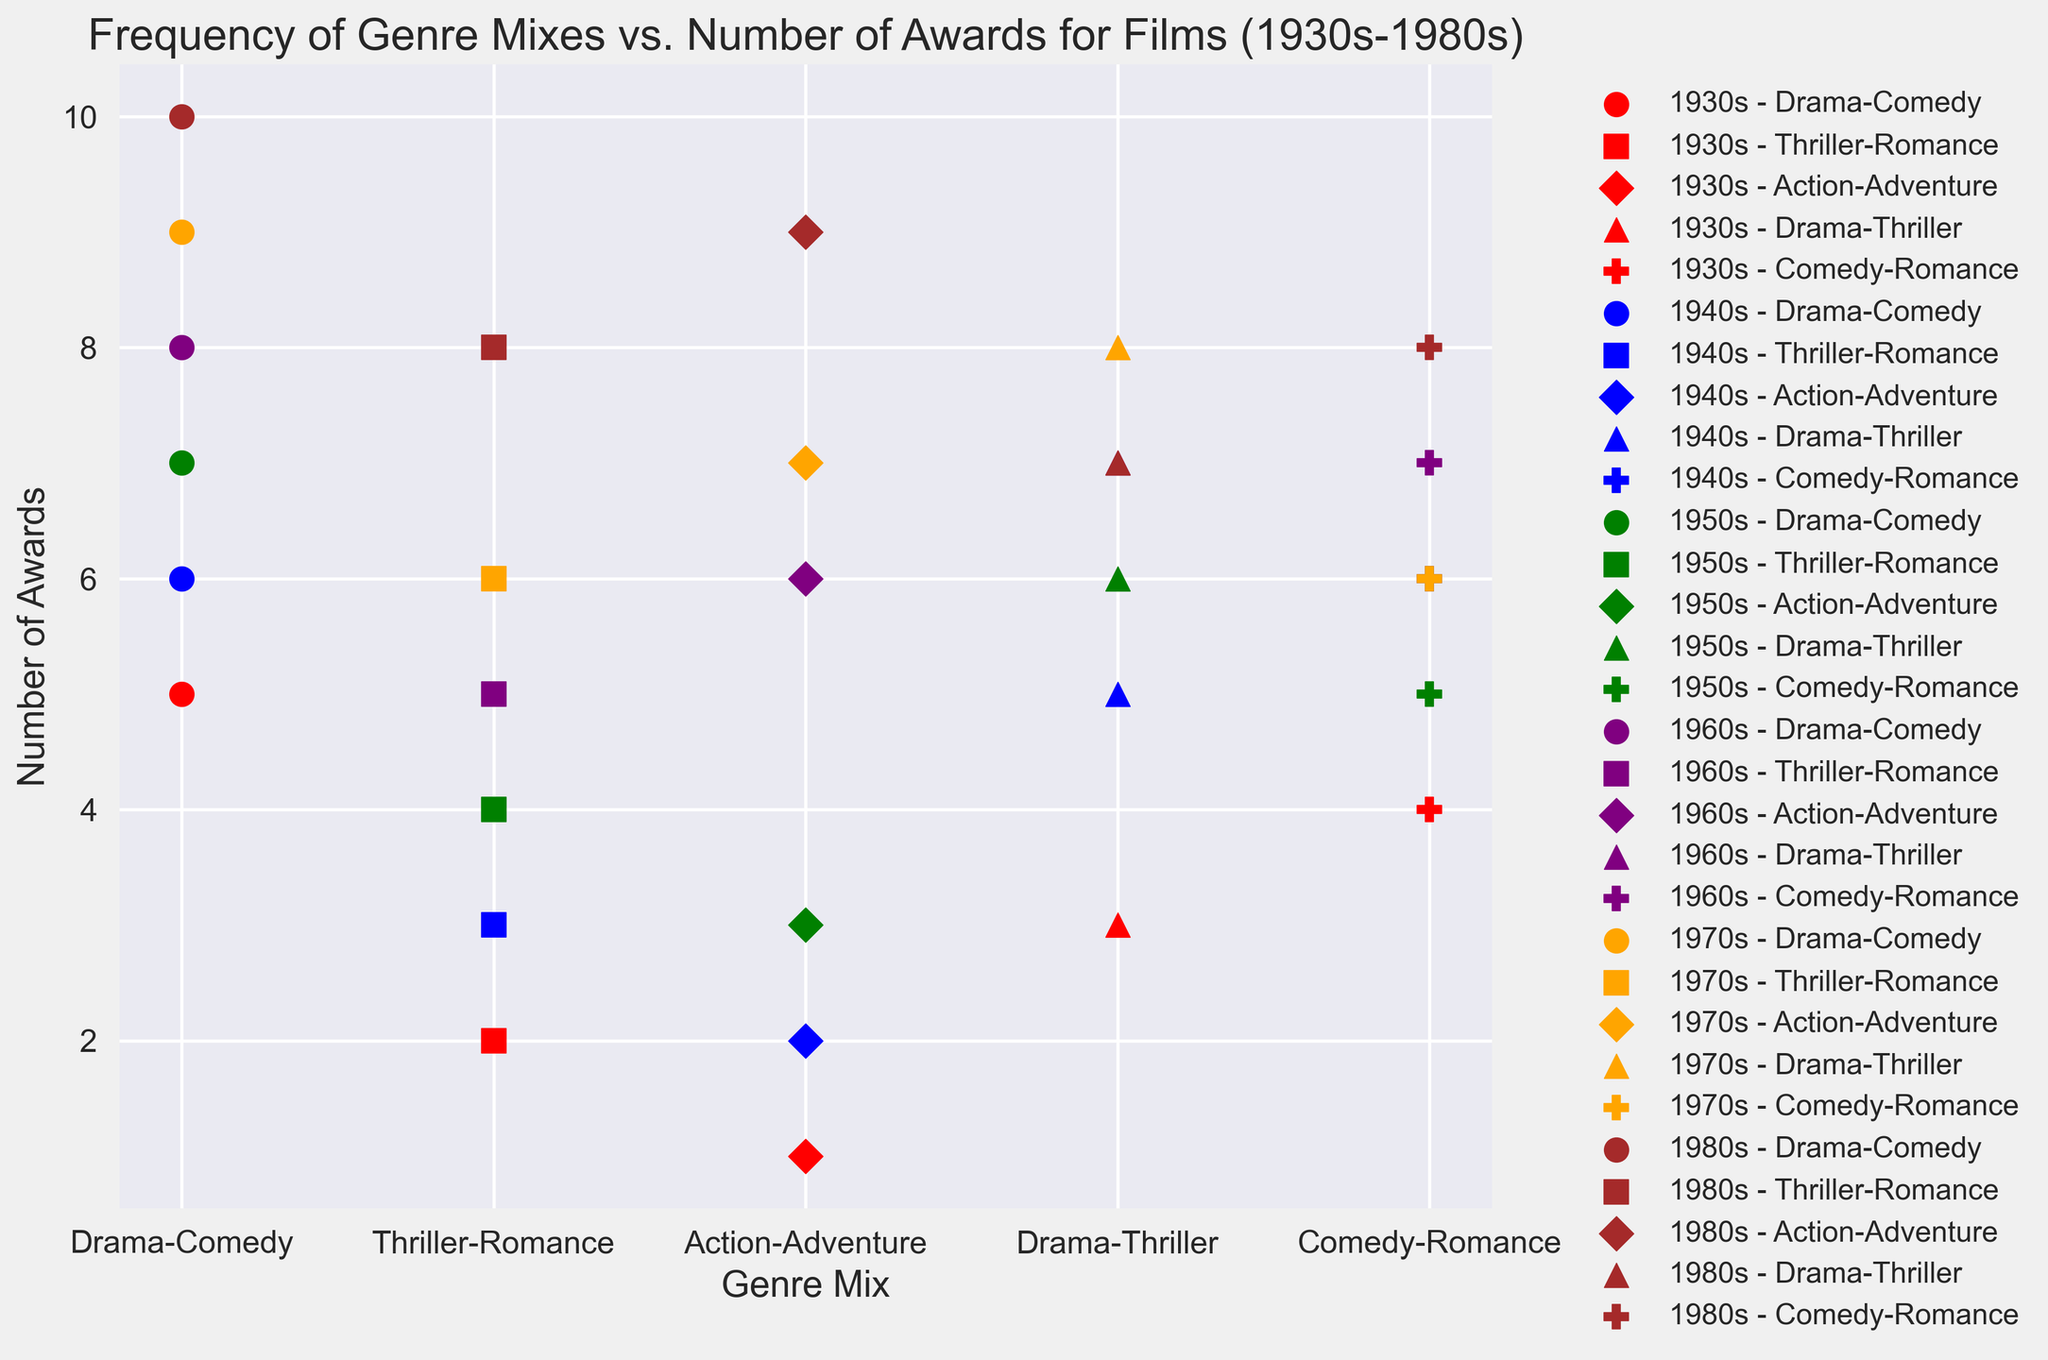Which era has the highest number of awards for the Drama-Comedy genre mix? Start by identifying the dots corresponding to the Drama-Comedy genre mix across all eras. The highest point on the y-axis is for the 1980s, with 10 awards.
Answer: 1980s Which two genres have the same number of awards in the 1960s? Look at the 1960s era and observe the y-axis values for each genre mix. Both Drama-Thriller and Comedy-Romance have 7 awards.
Answer: Drama-Thriller, Comedy-Romance What is the difference in the number of awards between the Action-Adventure and Thriller-Romance genres in the 1970s? Find the points for Action-Adventure (7 awards) and Thriller-Romance (6 awards) in the 1970s. Subtract the lower number from the higher: 7 - 6 = 1.
Answer: 1 Which genre mix had the least number of awards in the 1930s? Look at the points corresponding to the 1930s and identify the lowest point on the y-axis. Action-Adventure has the least with 1 award.
Answer: Action-Adventure Compare the number of awards for Comedy-Romance in the 1940s and 1980s. Which one has more? Locate Comedy-Romance points in the 1940s and 1980s. The 1940s has 6 awards, while the 1980s has 8 awards. The 1980s have more awards.
Answer: 1980s How many total awards did Drama-Thriller receive across all eras? Sum the number of awards for Drama-Thriller from each era: 1930s (3), 1940s (5), 1950s (6), 1960s (7), 1970s (8), 1980s (7). Total is 3 + 5 + 6 + 7 + 8 + 7 = 36.
Answer: 36 What is the average number of awards for the Thriller-Romance genre in the 1930s and 1940s? Obtain the number of awards for Thriller-Romance in the 1930s (2) and 1940s (3). Compute the average: (2 + 3) / 2 = 2.5.
Answer: 2.5 